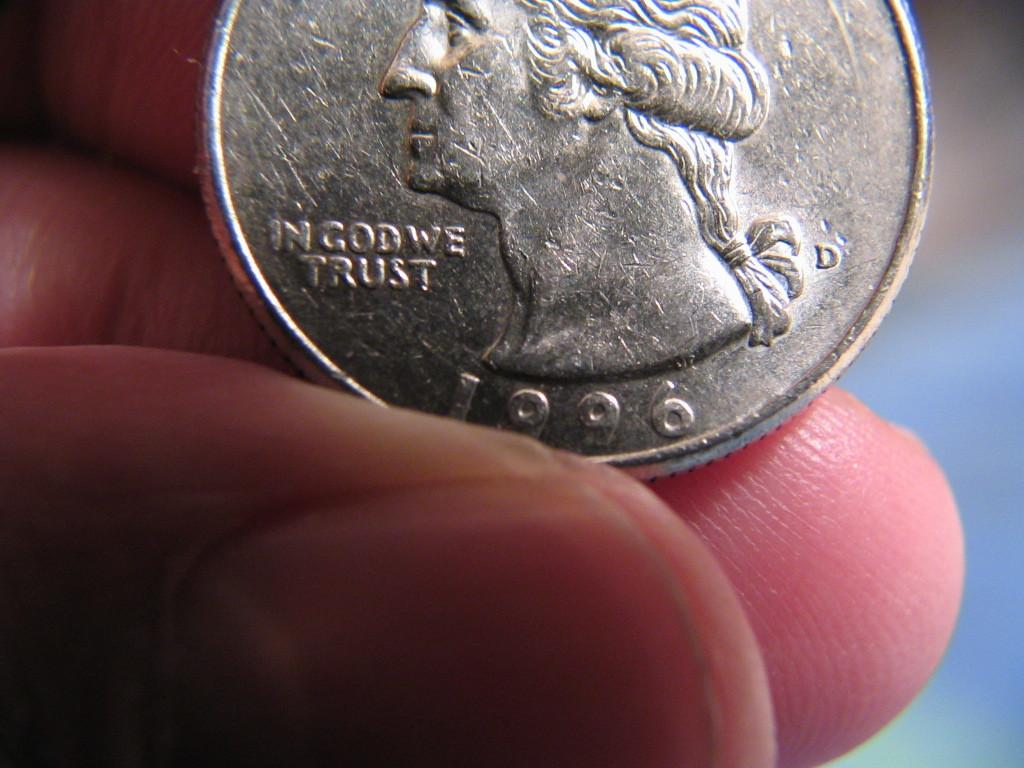Provide a one-sentence caption for the provided image. the year 1996 is on the silver coin. 